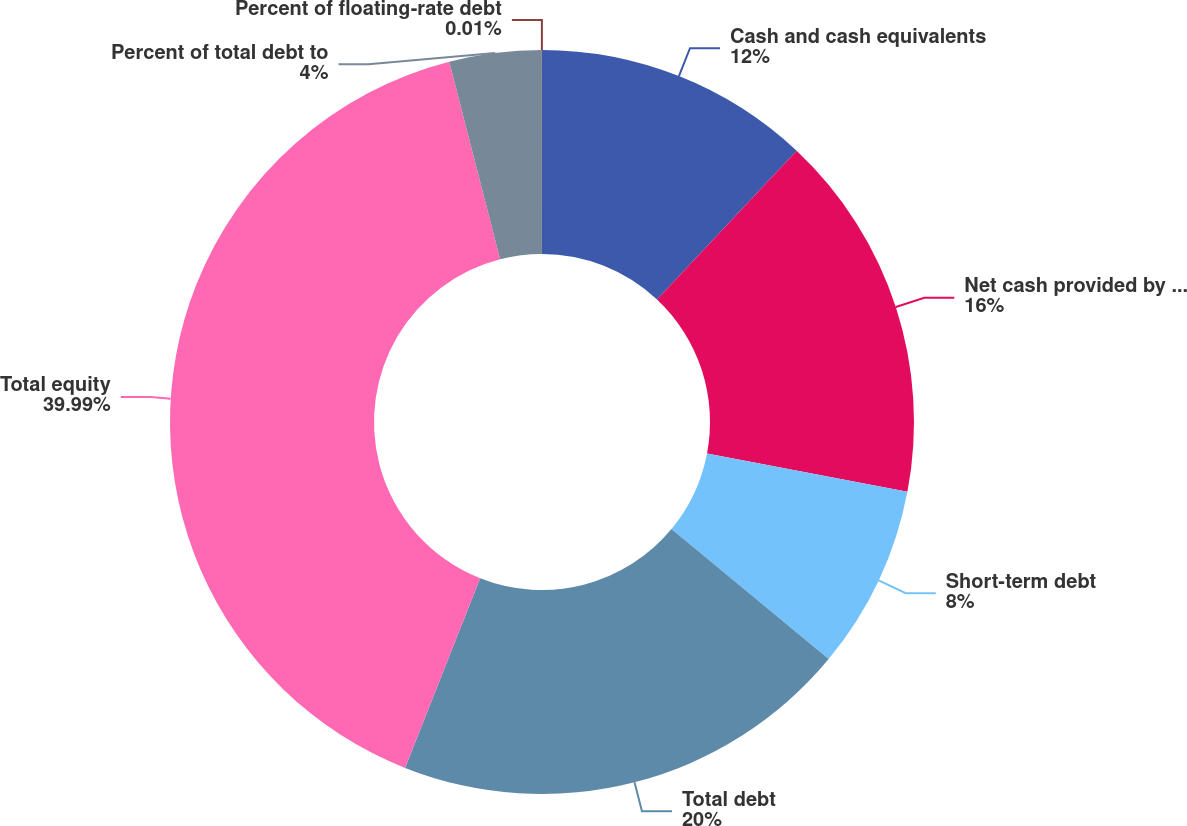Convert chart to OTSL. <chart><loc_0><loc_0><loc_500><loc_500><pie_chart><fcel>Cash and cash equivalents<fcel>Net cash provided by operating<fcel>Short-term debt<fcel>Total debt<fcel>Total equity<fcel>Percent of total debt to<fcel>Percent of floating-rate debt<nl><fcel>12.0%<fcel>16.0%<fcel>8.0%<fcel>20.0%<fcel>39.99%<fcel>4.0%<fcel>0.01%<nl></chart> 